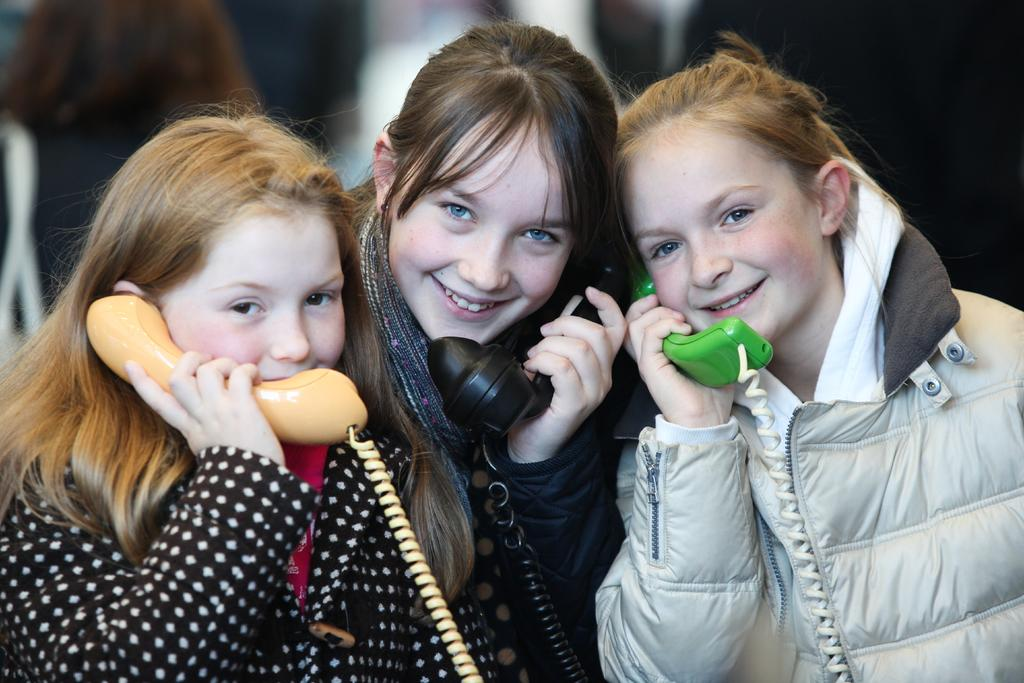How many people are in the image? There are three girls in the image. What are the girls doing in the image? The girls are standing in the image. What objects are the girls holding in their hands? The girls are holding telephones in their hands. What type of clothing are the girls wearing? The girls are wearing jackets. What song is the girl in the middle singing in the image? There is no indication in the image that the girls are singing, so it cannot be determined which song, if any, the girl in the middle might be singing. 